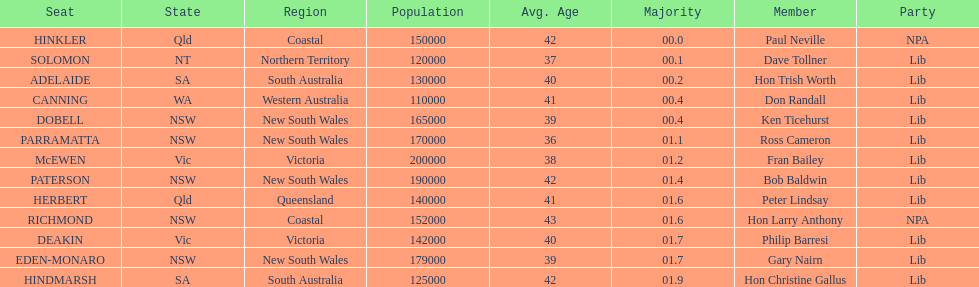Tell me the number of seats from nsw? 5. 